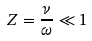<formula> <loc_0><loc_0><loc_500><loc_500>Z = \frac { \nu } { \omega } \ll 1</formula> 